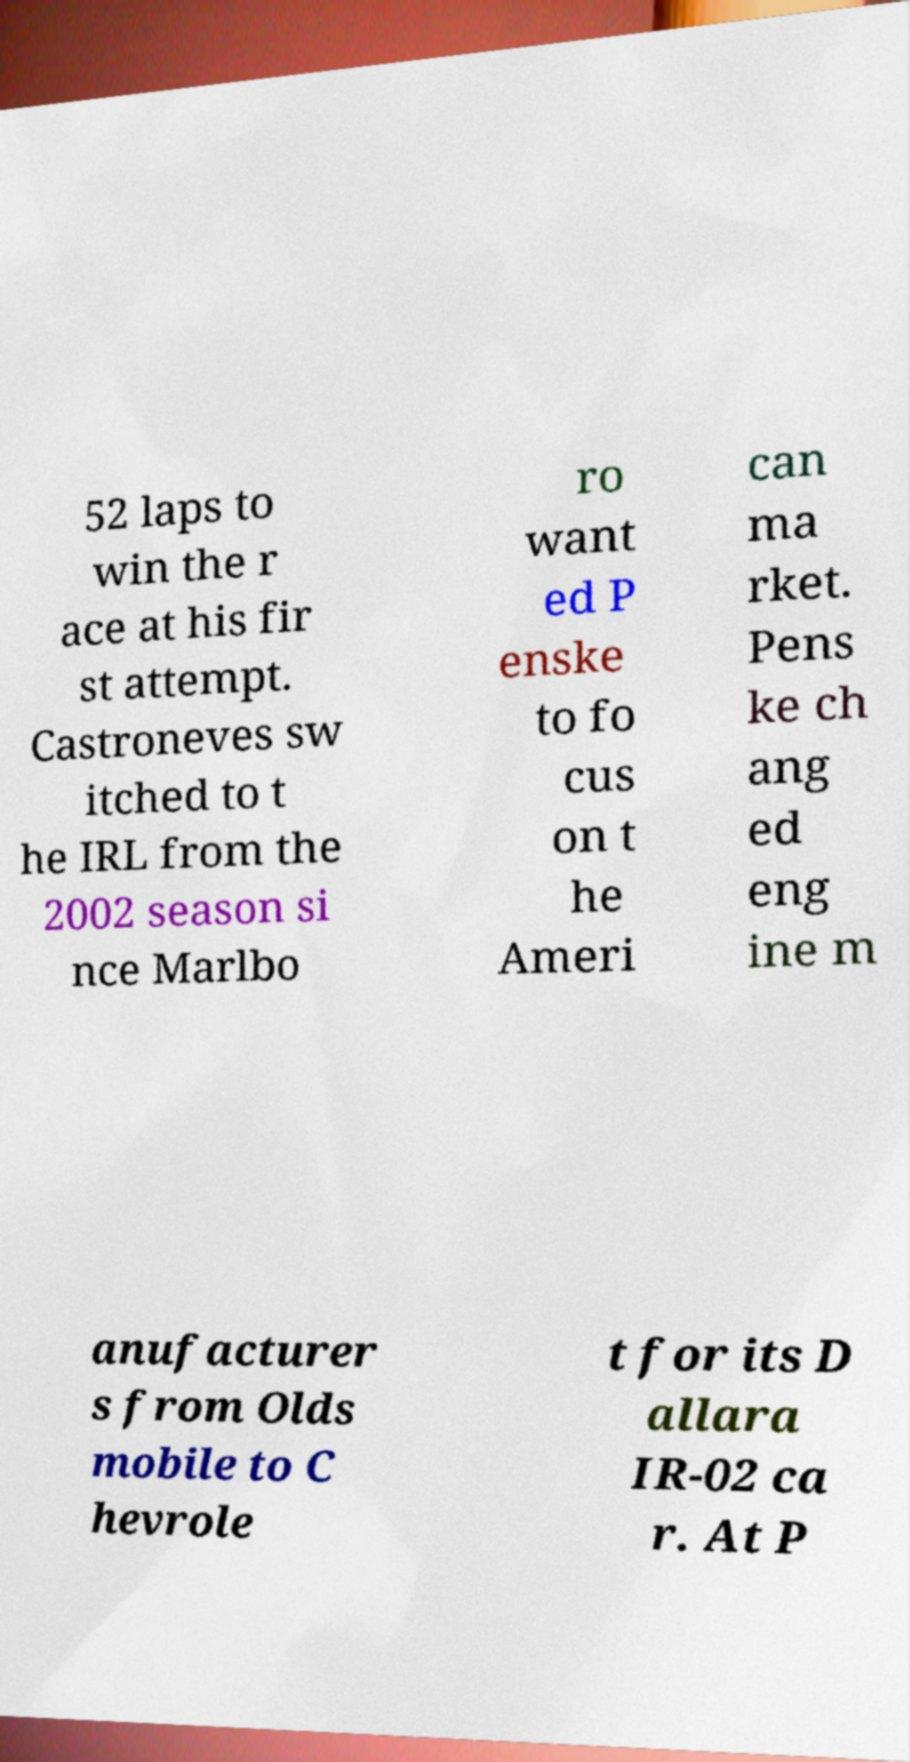Could you assist in decoding the text presented in this image and type it out clearly? 52 laps to win the r ace at his fir st attempt. Castroneves sw itched to t he IRL from the 2002 season si nce Marlbo ro want ed P enske to fo cus on t he Ameri can ma rket. Pens ke ch ang ed eng ine m anufacturer s from Olds mobile to C hevrole t for its D allara IR-02 ca r. At P 